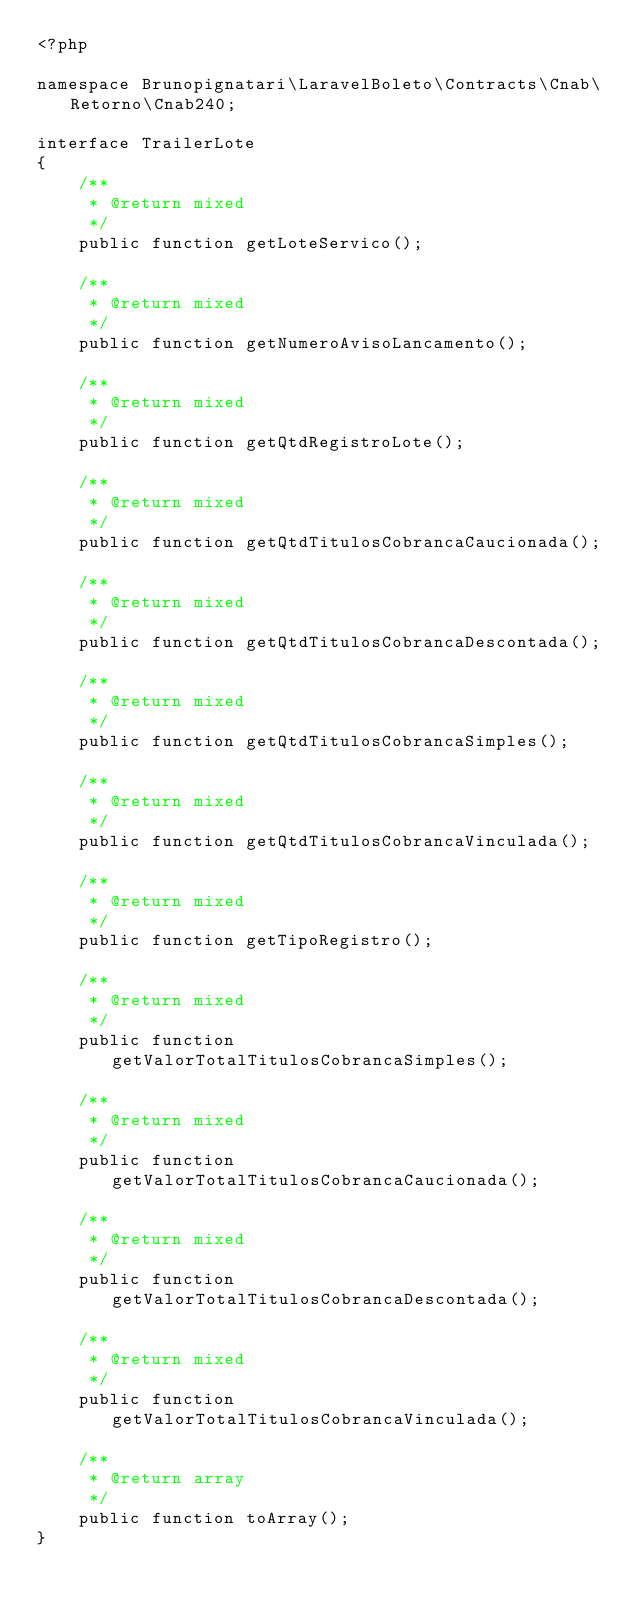Convert code to text. <code><loc_0><loc_0><loc_500><loc_500><_PHP_><?php

namespace Brunopignatari\LaravelBoleto\Contracts\Cnab\Retorno\Cnab240;

interface TrailerLote
{
    /**
     * @return mixed
     */
    public function getLoteServico();

    /**
     * @return mixed
     */
    public function getNumeroAvisoLancamento();

    /**
     * @return mixed
     */
    public function getQtdRegistroLote();

    /**
     * @return mixed
     */
    public function getQtdTitulosCobrancaCaucionada();

    /**
     * @return mixed
     */
    public function getQtdTitulosCobrancaDescontada();

    /**
     * @return mixed
     */
    public function getQtdTitulosCobrancaSimples();

    /**
     * @return mixed
     */
    public function getQtdTitulosCobrancaVinculada();

    /**
     * @return mixed
     */
    public function getTipoRegistro();

    /**
     * @return mixed
     */
    public function getValorTotalTitulosCobrancaSimples();

    /**
     * @return mixed
     */
    public function getValorTotalTitulosCobrancaCaucionada();

    /**
     * @return mixed
     */
    public function getValorTotalTitulosCobrancaDescontada();

    /**
     * @return mixed
     */
    public function getValorTotalTitulosCobrancaVinculada();

    /**
     * @return array
     */
    public function toArray();
}
</code> 